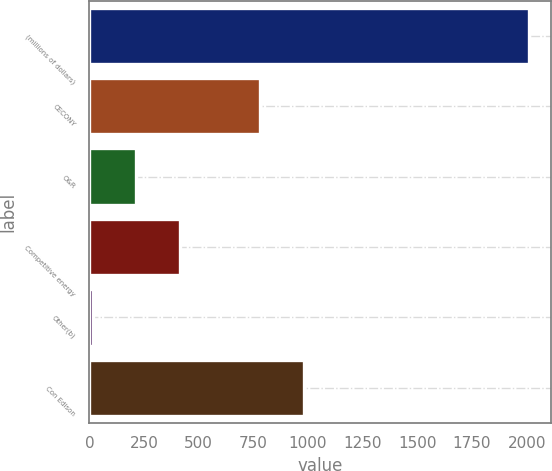Convert chart to OTSL. <chart><loc_0><loc_0><loc_500><loc_500><bar_chart><fcel>(millions of dollars)<fcel>CECONY<fcel>O&R<fcel>Competitive energy<fcel>Other(b)<fcel>Con Edison<nl><fcel>2009<fcel>781<fcel>214.4<fcel>413.8<fcel>15<fcel>980.4<nl></chart> 